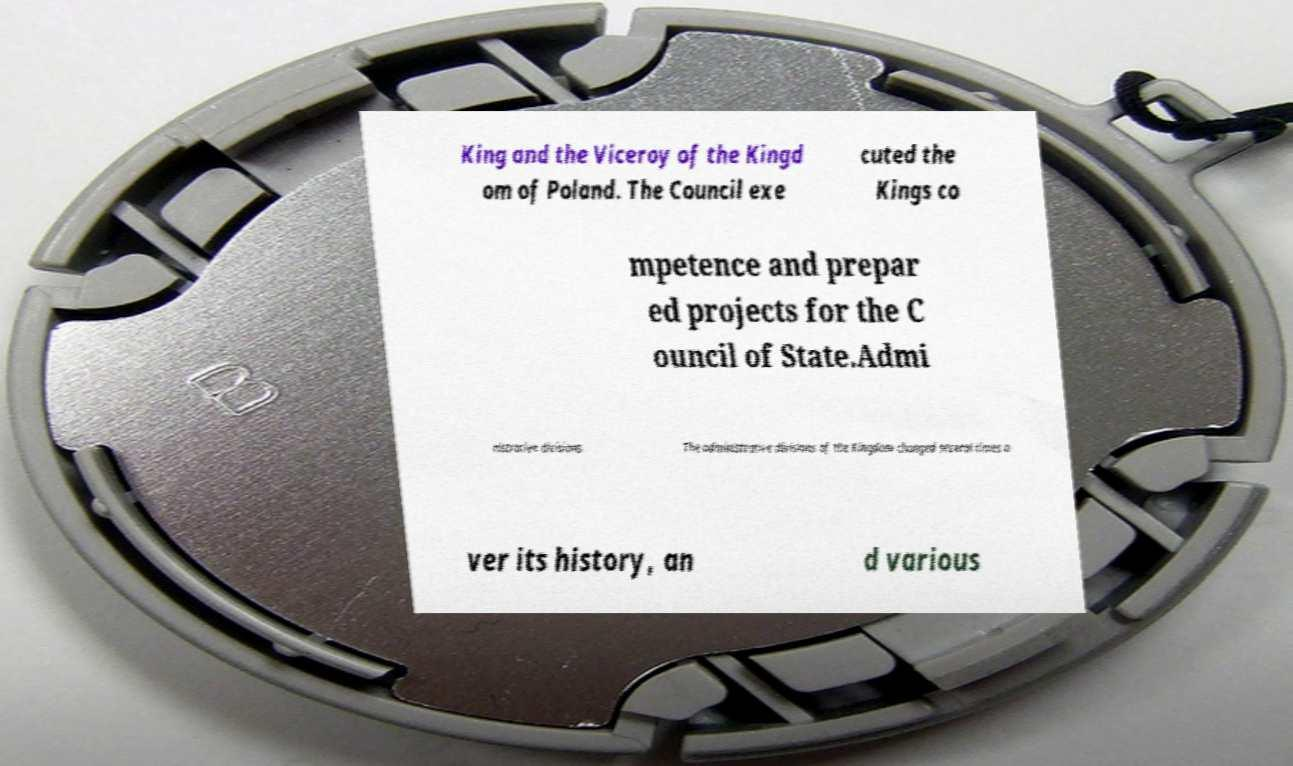I need the written content from this picture converted into text. Can you do that? King and the Viceroy of the Kingd om of Poland. The Council exe cuted the Kings co mpetence and prepar ed projects for the C ouncil of State.Admi nistrative divisions. The administrative divisions of the Kingdom changed several times o ver its history, an d various 